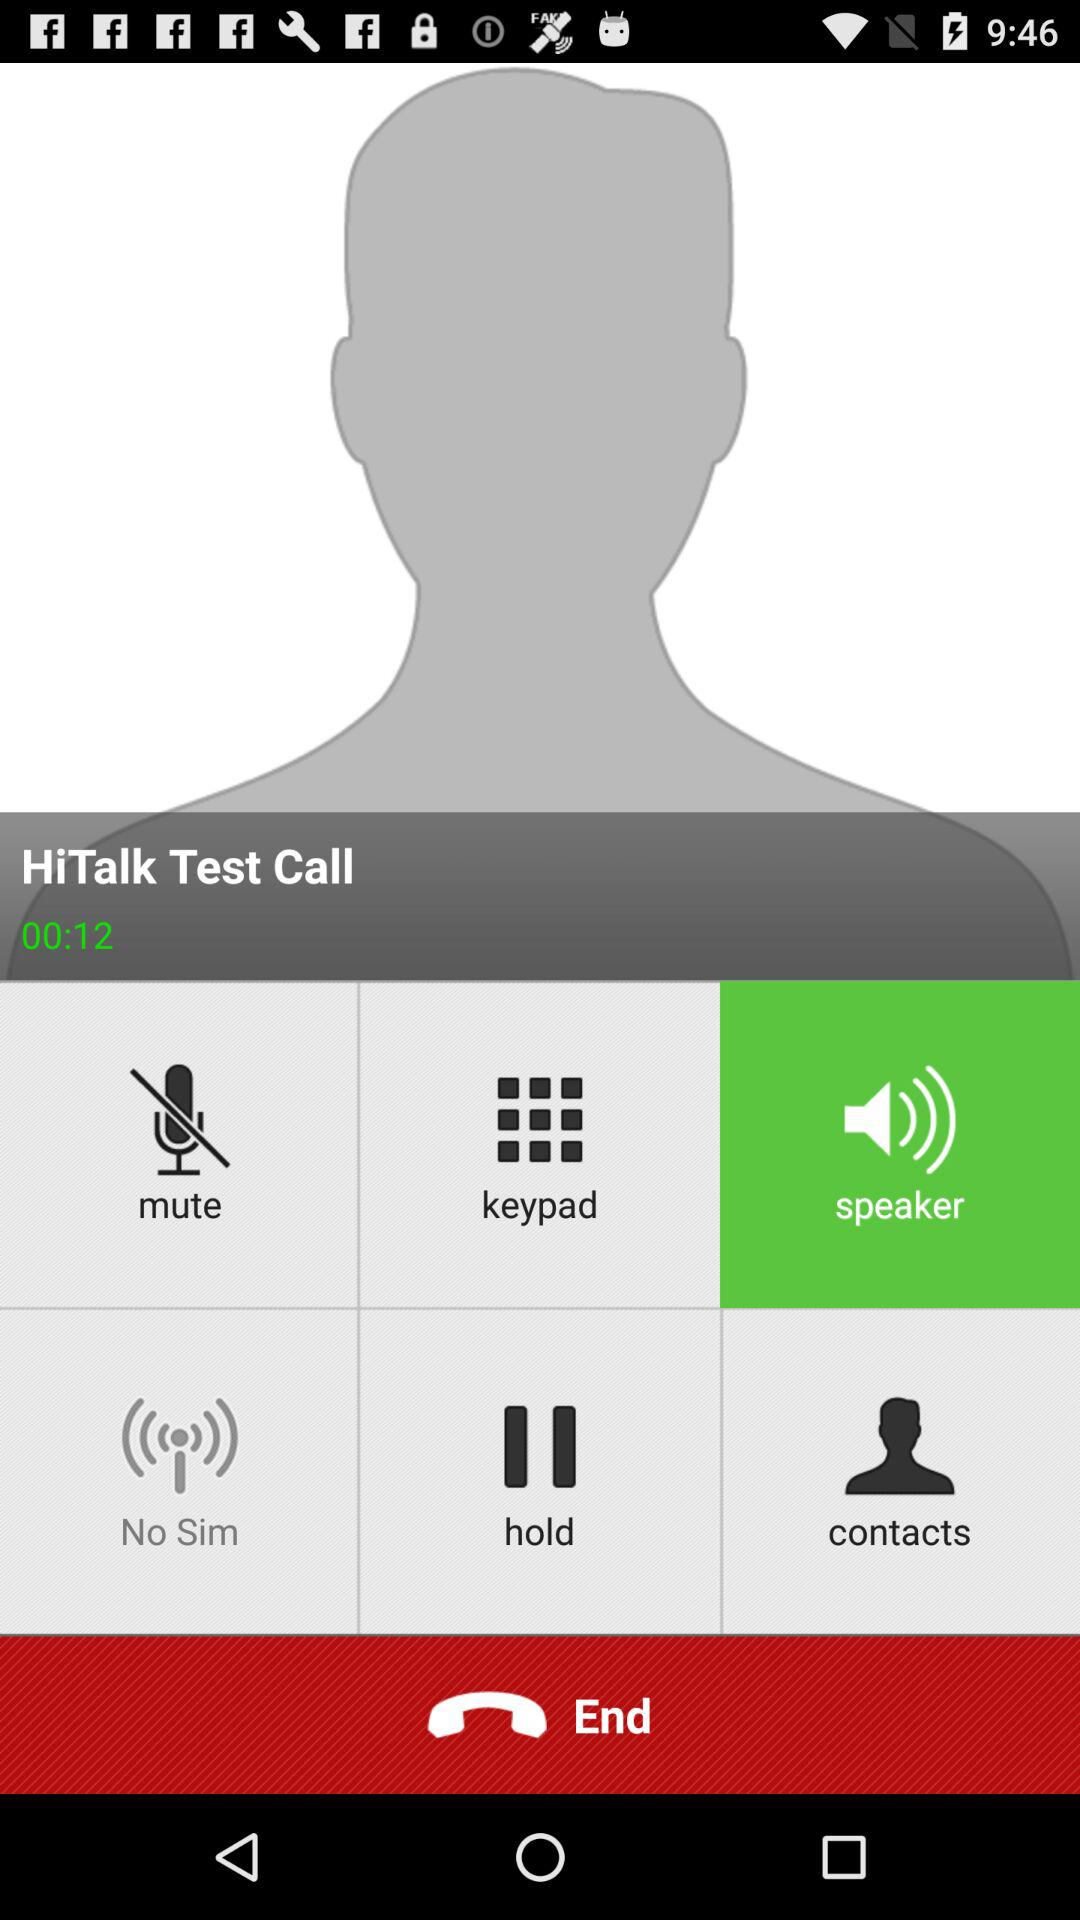Who is the caller? The caller is "HiTalk Test Call". 